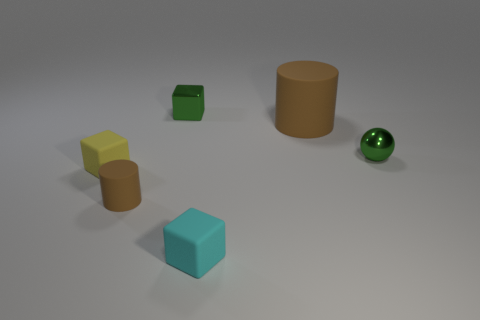What shapes can you identify in the image? In the image, there are several three-dimensional shapes including a large cylinder, small cylinder, cube, sphere, and a rectangular prism. Do these objects share any similarities? Yes, the objects all have smooth surfaces and are solid colors. Additionally, they are all situated on the same flat surface, suggesting they were arranged for display or comparison. 